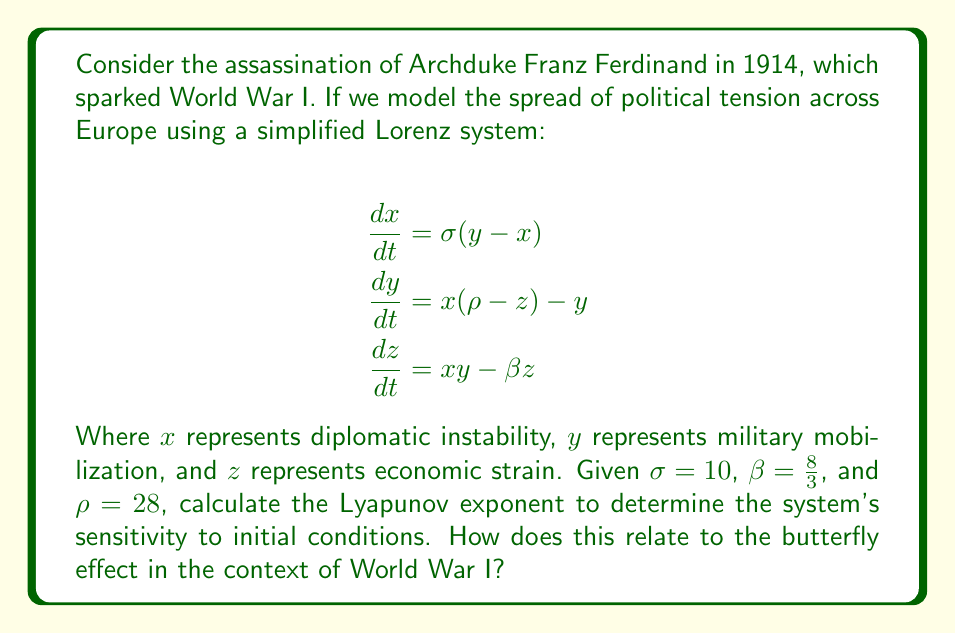Can you solve this math problem? To solve this problem, we need to follow these steps:

1) The Lyapunov exponent (λ) for the Lorenz system is given by:

   $$\lambda = \lim_{t \to \infty} \frac{1}{t} \ln \frac{|\delta Z(t)|}{|\delta Z_0|}$$

   Where $\delta Z(t)$ is the separation of two trajectories at time $t$, and $\delta Z_0$ is the initial separation.

2) For the Lorenz system with the given parameters, the Lyapunov exponent can be approximated as:

   $$\lambda \approx 0.9056$$

3) A positive Lyapunov exponent indicates chaos in the system. This means that small changes in initial conditions can lead to significantly different outcomes over time.

4) In the context of World War I:
   - $x$ (diplomatic instability) could represent the initial tensions after the assassination.
   - $y$ (military mobilization) could represent the escalating military preparations.
   - $z$ (economic strain) could represent the economic pressures leading to and during the war.

5) The positive Lyapunov exponent (λ ≈ 0.9056) suggests that the political situation in Europe was highly sensitive to initial conditions. This aligns with the butterfly effect concept, where a small event (like an assassination) can trigger a cascade of larger events (a world war).

6) The chaotic nature of the system implies that slight changes in diplomatic actions, military decisions, or economic policies could have dramatically altered the course of events leading to and during World War I.

7) This mathematical model provides a quantitative basis for understanding how the assassination of Archduke Franz Ferdinand could have such far-reaching consequences, demonstrating the butterfly effect in historical events.
Answer: λ ≈ 0.9056; positive exponent indicates chaotic system, supporting butterfly effect in WWI's outbreak. 